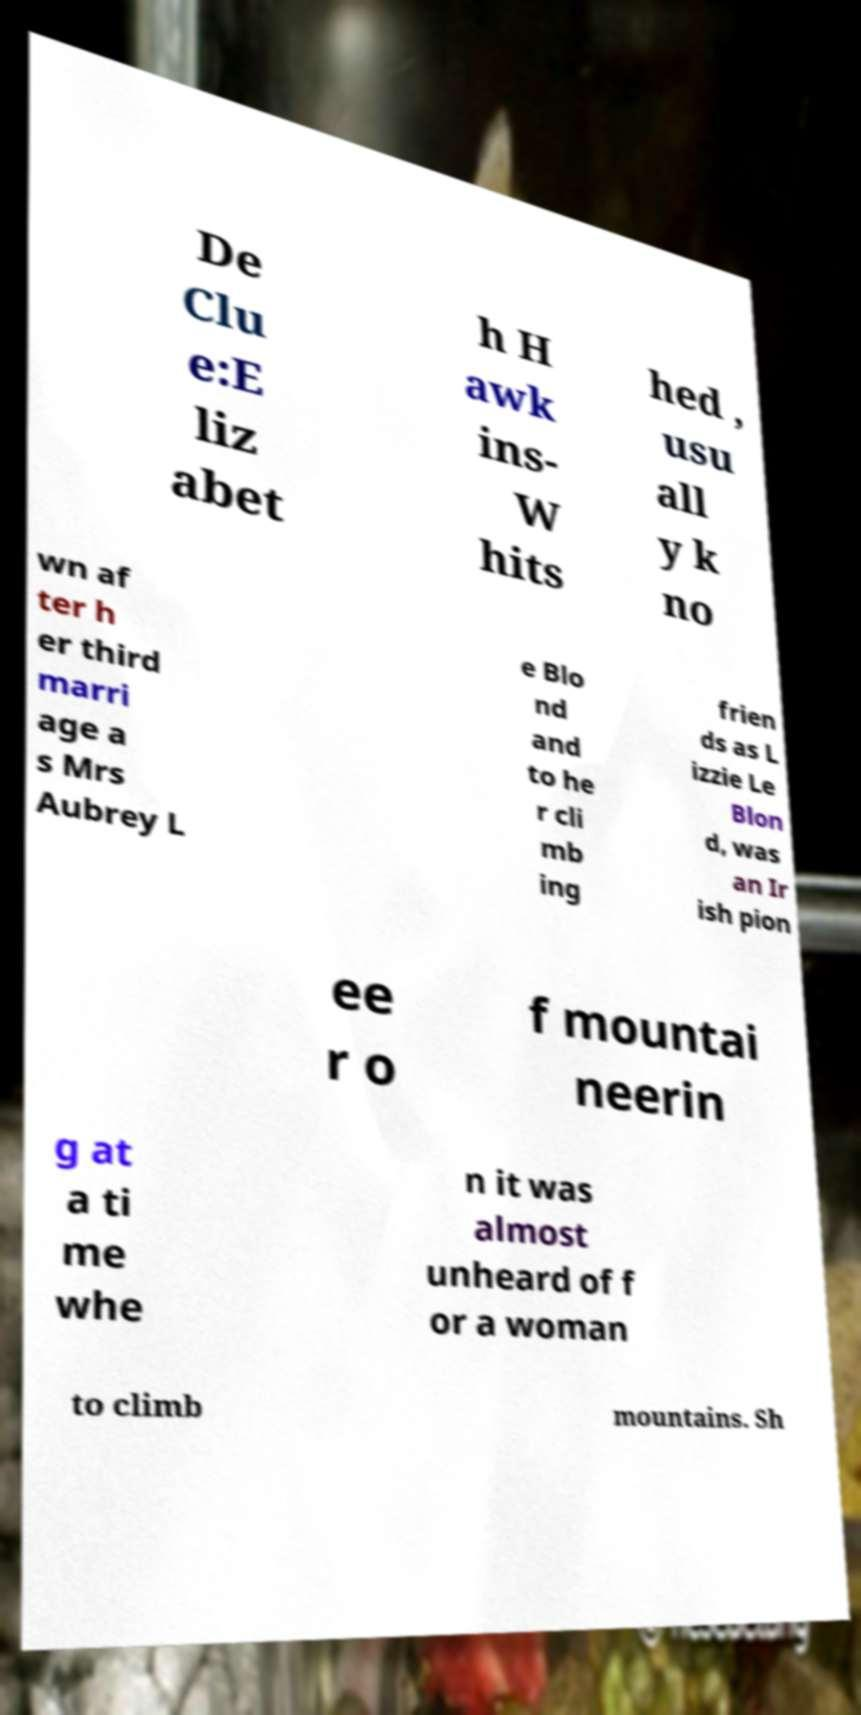For documentation purposes, I need the text within this image transcribed. Could you provide that? De Clu e:E liz abet h H awk ins- W hits hed , usu all y k no wn af ter h er third marri age a s Mrs Aubrey L e Blo nd and to he r cli mb ing frien ds as L izzie Le Blon d, was an Ir ish pion ee r o f mountai neerin g at a ti me whe n it was almost unheard of f or a woman to climb mountains. Sh 